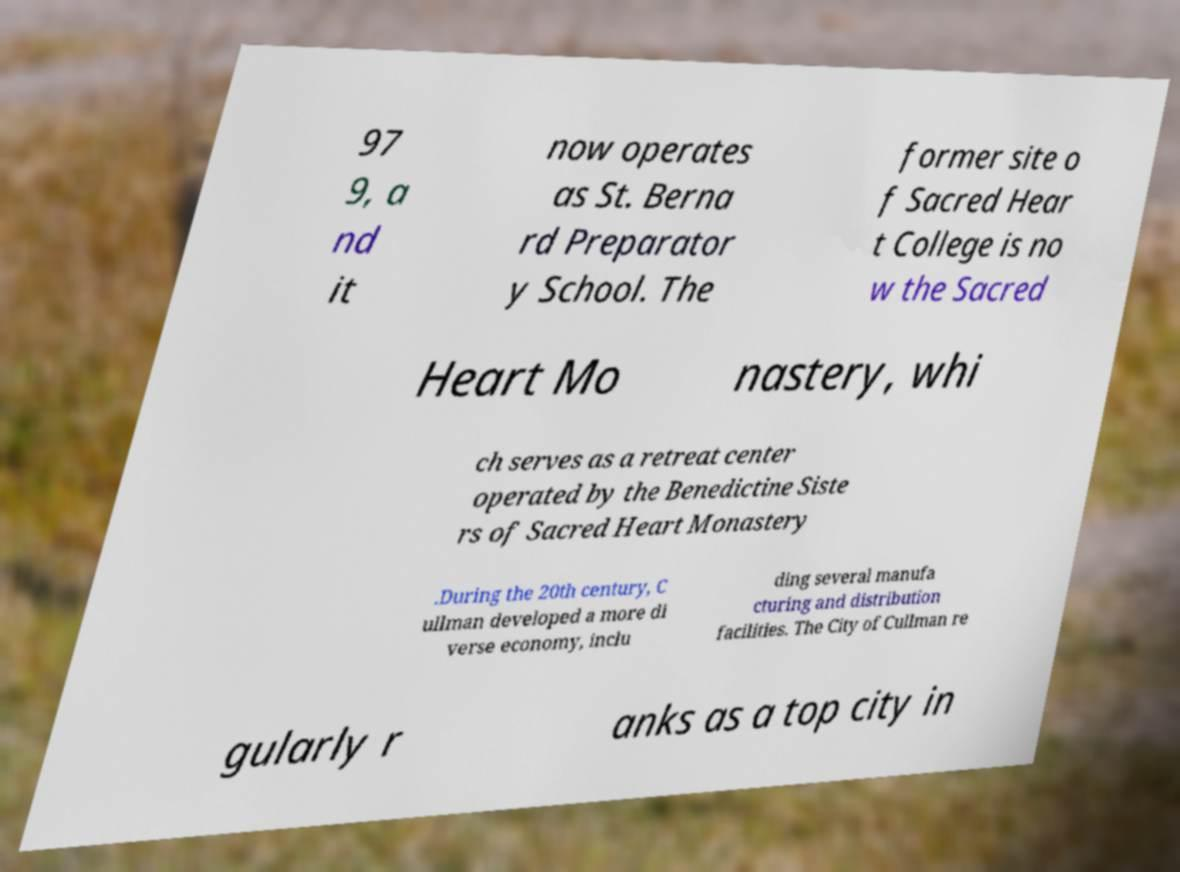Can you read and provide the text displayed in the image?This photo seems to have some interesting text. Can you extract and type it out for me? 97 9, a nd it now operates as St. Berna rd Preparator y School. The former site o f Sacred Hear t College is no w the Sacred Heart Mo nastery, whi ch serves as a retreat center operated by the Benedictine Siste rs of Sacred Heart Monastery .During the 20th century, C ullman developed a more di verse economy, inclu ding several manufa cturing and distribution facilities. The City of Cullman re gularly r anks as a top city in 